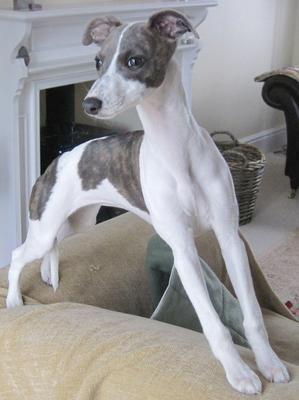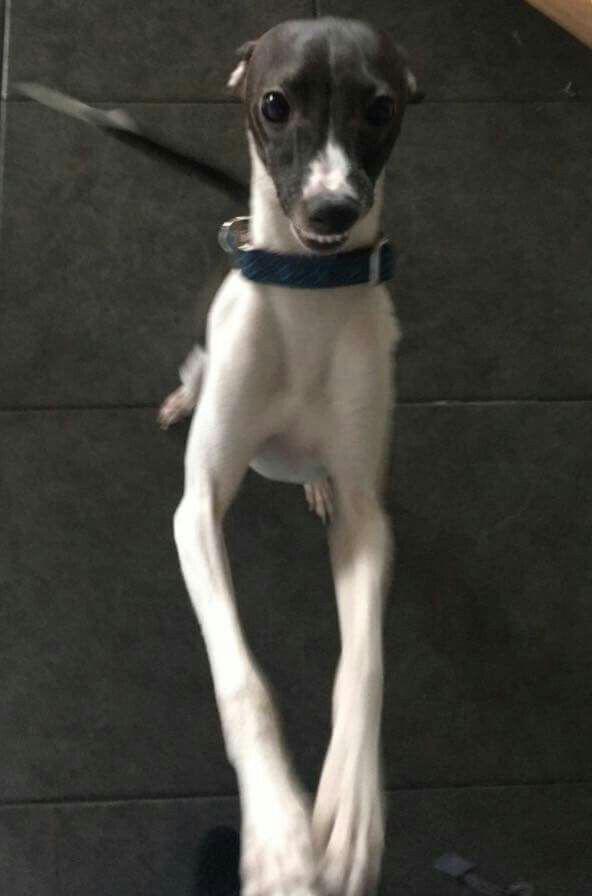The first image is the image on the left, the second image is the image on the right. Assess this claim about the two images: "There is at least one dog outside in the image on the left.". Correct or not? Answer yes or no. No. The first image is the image on the left, the second image is the image on the right. Analyze the images presented: Is the assertion "A gray puppy with white paws is standing in front of another puppy in one image." valid? Answer yes or no. No. 